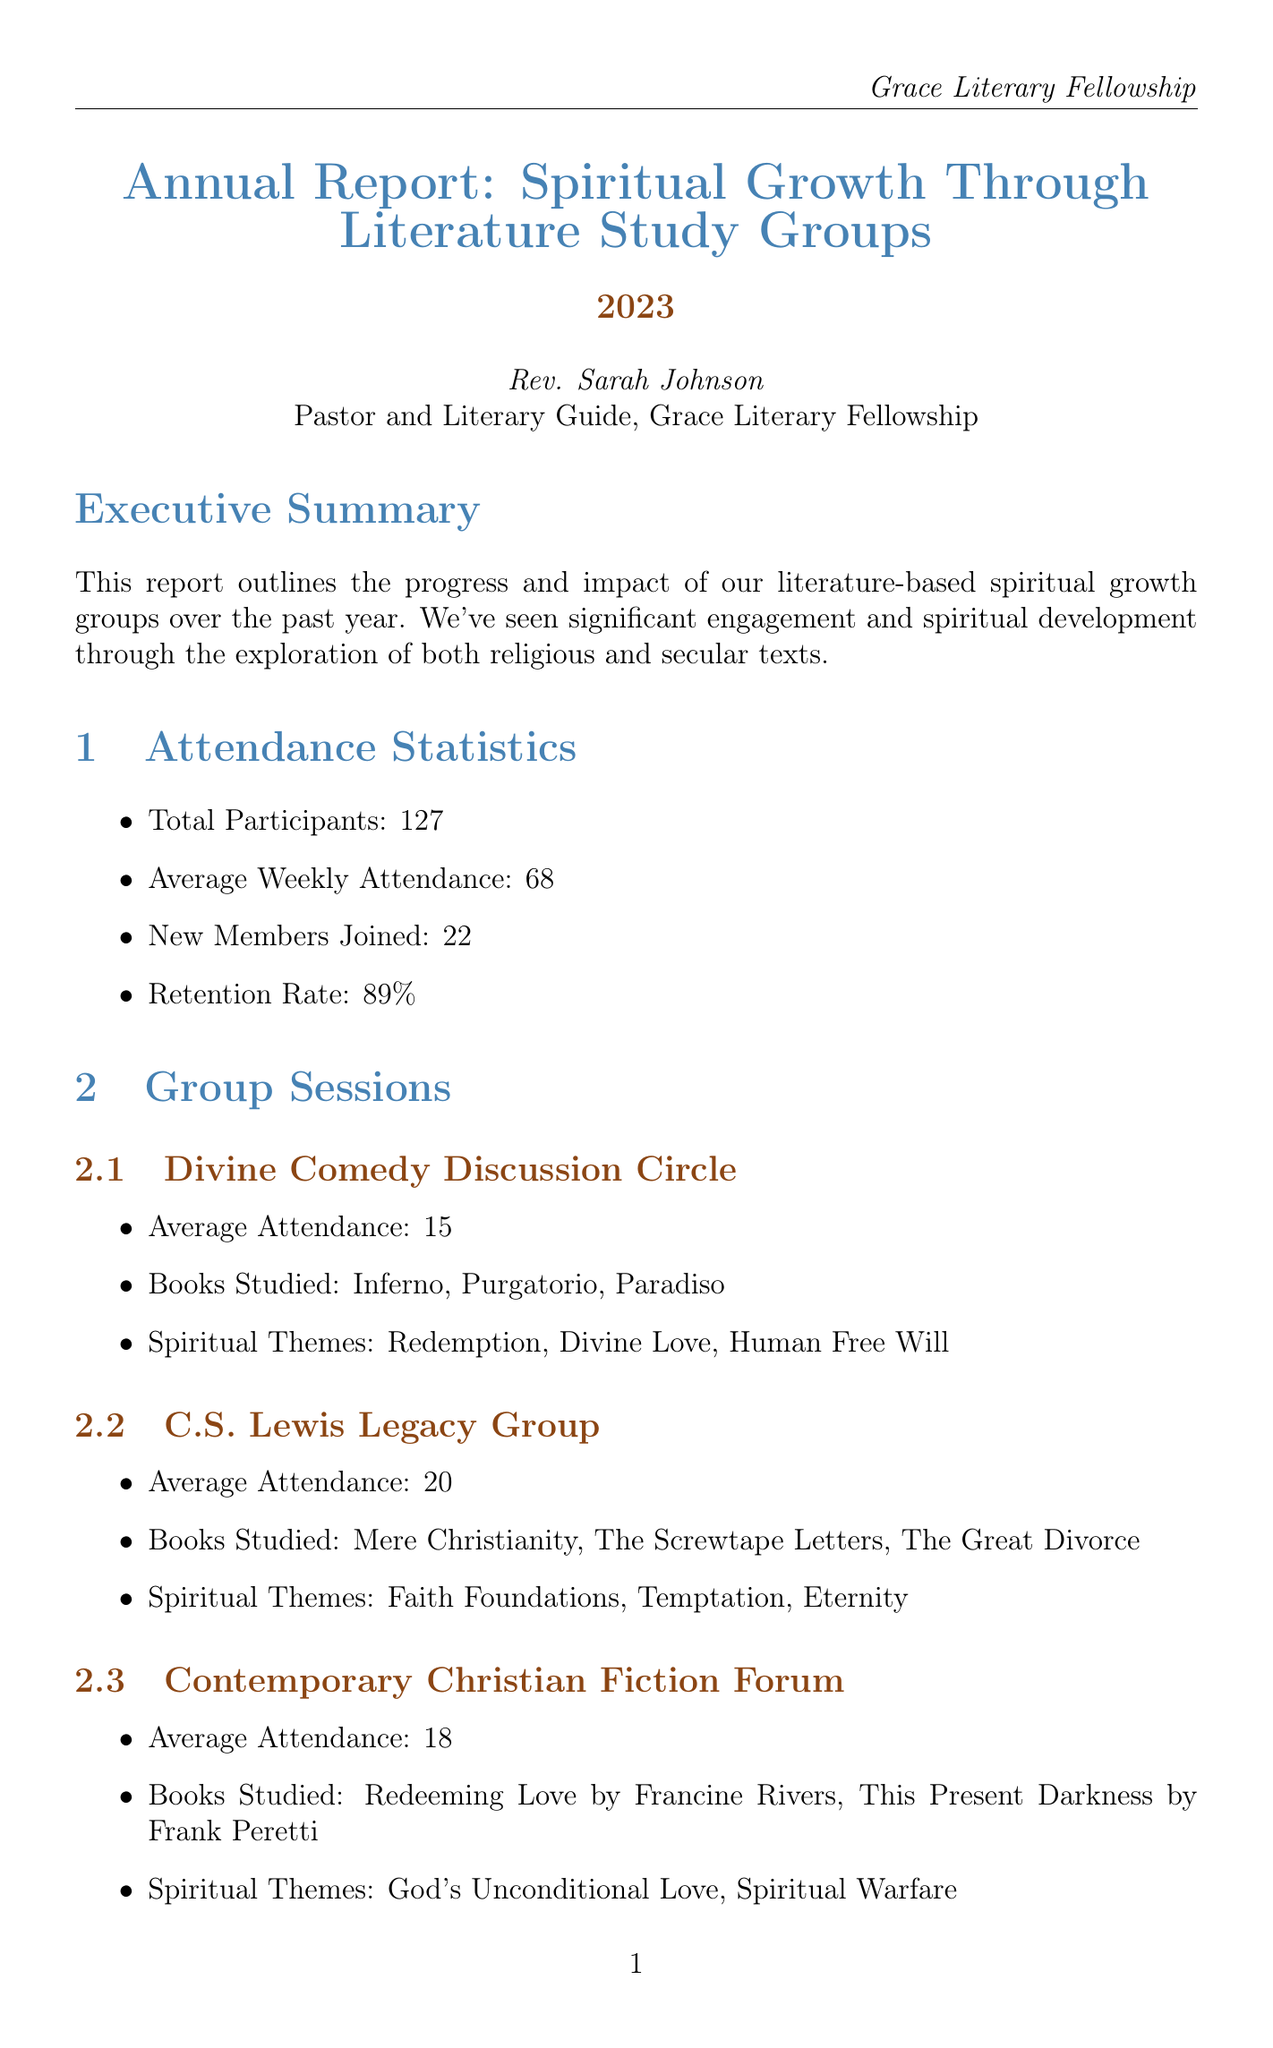What is the total number of participants? The total number of participants is listed in the attendance statistics section of the document.
Answer: 127 What is the retention rate of the groups? The retention rate is mentioned in the attendance statistics, reflecting the percentage of members who continue participating.
Answer: 89% Which group had the highest average attendance? This question involves comparing the average attendance of all groups listed in the document.
Answer: C.S. Lewis Legacy Group What percentage of participants reported a more consistent prayer life? This percentage is included in the spiritual growth metrics section and indicates improvement in the prayer lives of attendees.
Answer: 81% Who provided feedback on the Contemporary Christian Fiction Forum? This question asks for the name of a specific individual from the member feedback section.
Answer: Olivia Patel What is one of the goals for next year? This question involves identifying one of the objectives outlined for the upcoming year in the goals section.
Answer: Introduce a new group focused on global Christian literature What spiritual theme is focused on in the Divine Comedy Discussion Circle? This question requires identifying a specific theme discussed in one of the group sessions listed in the document.
Answer: Redemption How many new members joined this year? The number of new members is specified in the attendance statistics section of the report.
Answer: 22 